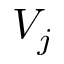<formula> <loc_0><loc_0><loc_500><loc_500>V _ { j }</formula> 